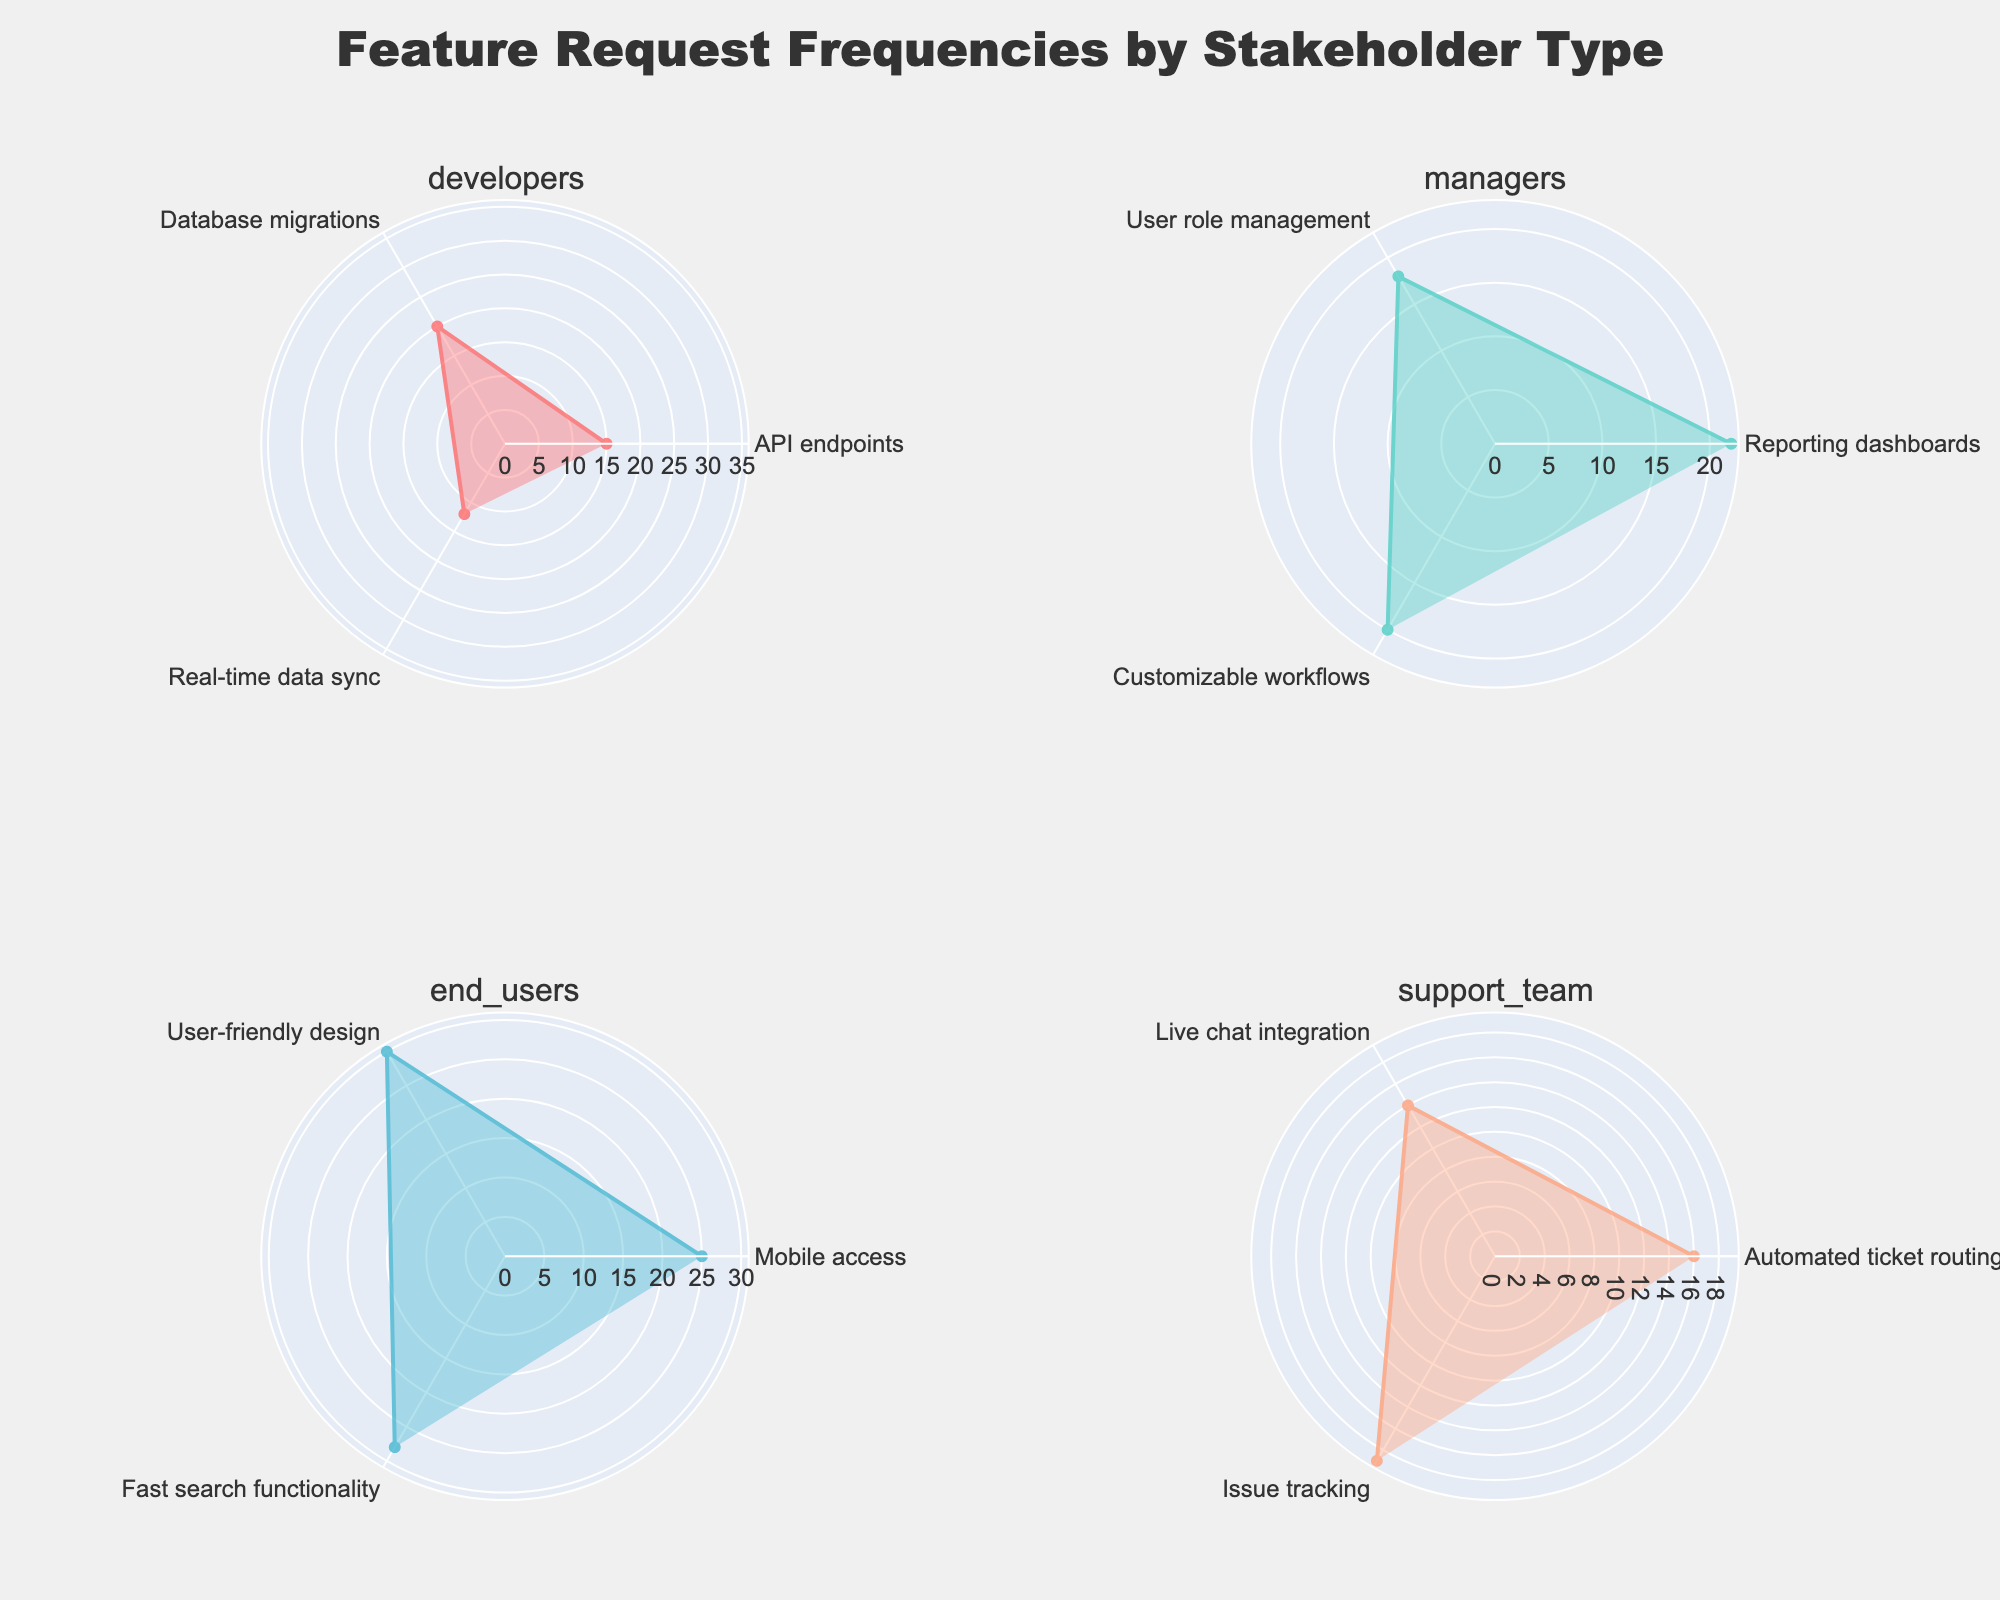How many feature requests do managers have in total? By aggregating the frequencies for managers' feature requests (Reporting dashboards, User role management, Customizable workflows) which are 22, 18, and 20 respectively, we get the total: 22 + 18 + 20 = 60.
Answer: 60 Which stakeholder type has the highest single feature request frequency? Reviewing each subplot, the highest frequency among developers is 20, managers 22, end users 30, and support team 19. End users have the highest frequency with 30 on User-friendly design.
Answer: End users What's the difference in frequency between the most requested feature by end users and developers? The highest frequencies for end users and developers are 30 (User-friendly design) and 20 (Database migrations) respectively. The difference is calculated as 30 - 20 = 10.
Answer: 10 What is the average frequency of feature requests for the support team? The support team's feature requests frequencies are 16 (Automated ticket routing), 14 (Live chat integration), and 19 (Issue tracking). The average is calculated as (16 + 14 + 19) / 3 ≈ 16.33.
Answer: 16.33 Which feature had the highest frequency among all stakeholder types? Looking at all the subplots, the feature with the highest frequency is "User-friendly design" within the end users' subplot with a frequency of 30.
Answer: User-friendly design How many features have frequencies greater than 25? The subplots show that "Mobile access" (25), "User-friendly design" (30), and "Fast search functionality" (28) from end users surpass the threshold of 25 frequency.
Answer: 3 Which stakeholder type has the most evenly distributed feature request frequencies? Comparing the spreads, developers have the most evenly distributed frequencies (15, 20, 12), varying by a range of 8. End users (25, 30, 28) have frequency differences ranging up to 5, which is narrower, making end users more even.
Answer: End users What's the median frequency of feature requests for developers? Developers have frequencies of 15 (API endpoints), 20 (Database migrations), and 12 (Real-time data sync). Arranging them in ascending order gives 12, 15, and 20, with the median being the middle value, which is 15.
Answer: 15 What is the sum of the feature frequencies for features that begin with the letter 'U'? Identifying features starting with 'U', we have "User role management" (18) and "User-friendly design" (30). The sum is 18 + 30 = 48.
Answer: 48 